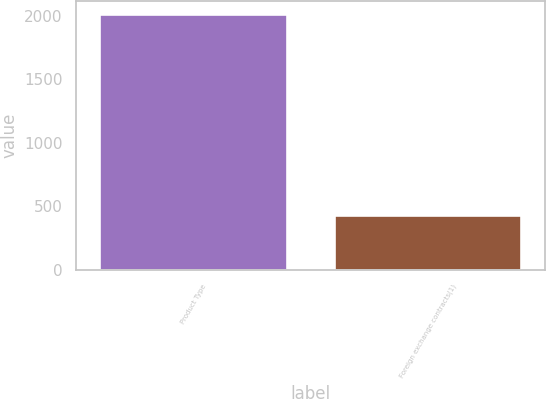<chart> <loc_0><loc_0><loc_500><loc_500><bar_chart><fcel>Product Type<fcel>Foreign exchange contracts(1)<nl><fcel>2015<fcel>434<nl></chart> 